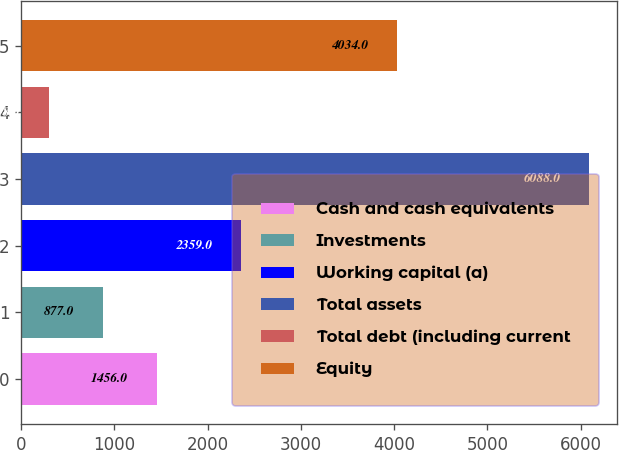<chart> <loc_0><loc_0><loc_500><loc_500><bar_chart><fcel>Cash and cash equivalents<fcel>Investments<fcel>Working capital (a)<fcel>Total assets<fcel>Total debt (including current<fcel>Equity<nl><fcel>1456<fcel>877<fcel>2359<fcel>6088<fcel>298<fcel>4034<nl></chart> 